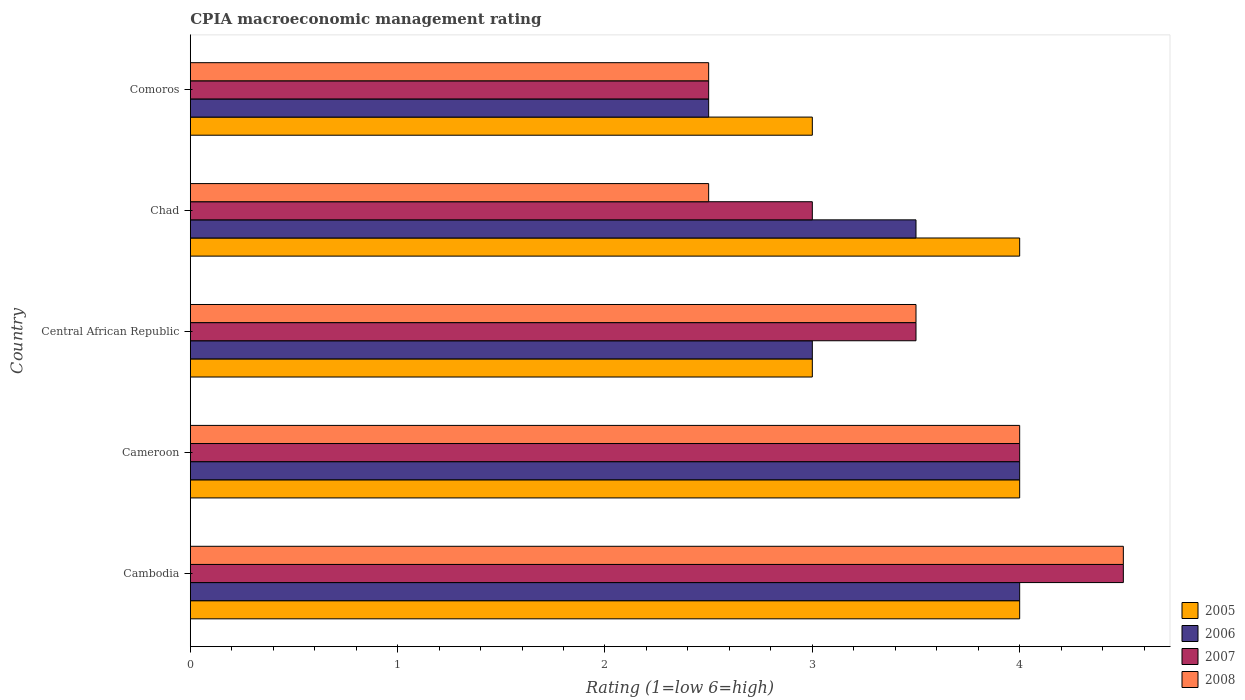Are the number of bars per tick equal to the number of legend labels?
Your answer should be very brief. Yes. Are the number of bars on each tick of the Y-axis equal?
Make the answer very short. Yes. How many bars are there on the 5th tick from the top?
Provide a succinct answer. 4. What is the label of the 1st group of bars from the top?
Your response must be concise. Comoros. What is the CPIA rating in 2007 in Cambodia?
Your answer should be very brief. 4.5. In which country was the CPIA rating in 2006 maximum?
Make the answer very short. Cambodia. In which country was the CPIA rating in 2006 minimum?
Provide a short and direct response. Comoros. What is the total CPIA rating in 2007 in the graph?
Your response must be concise. 17.5. What is the difference between the CPIA rating in 2006 in Cameroon and that in Central African Republic?
Your response must be concise. 1. What is the difference between the CPIA rating in 2005 in Comoros and the CPIA rating in 2007 in Cambodia?
Your answer should be compact. -1.5. What is the average CPIA rating in 2005 per country?
Keep it short and to the point. 3.6. What is the difference between the CPIA rating in 2005 and CPIA rating in 2007 in Comoros?
Keep it short and to the point. 0.5. What is the ratio of the CPIA rating in 2005 in Cambodia to that in Central African Republic?
Offer a very short reply. 1.33. Is the CPIA rating in 2008 in Cambodia less than that in Comoros?
Your answer should be very brief. No. What is the difference between the highest and the second highest CPIA rating in 2008?
Ensure brevity in your answer.  0.5. What is the difference between the highest and the lowest CPIA rating in 2005?
Your answer should be compact. 1. In how many countries, is the CPIA rating in 2006 greater than the average CPIA rating in 2006 taken over all countries?
Give a very brief answer. 3. Is it the case that in every country, the sum of the CPIA rating in 2007 and CPIA rating in 2008 is greater than the sum of CPIA rating in 2005 and CPIA rating in 2006?
Provide a short and direct response. No. What does the 1st bar from the top in Chad represents?
Your answer should be very brief. 2008. How many countries are there in the graph?
Make the answer very short. 5. Does the graph contain any zero values?
Offer a very short reply. No. How are the legend labels stacked?
Give a very brief answer. Vertical. What is the title of the graph?
Give a very brief answer. CPIA macroeconomic management rating. What is the label or title of the X-axis?
Make the answer very short. Rating (1=low 6=high). What is the label or title of the Y-axis?
Provide a succinct answer. Country. What is the Rating (1=low 6=high) of 2005 in Cambodia?
Make the answer very short. 4. What is the Rating (1=low 6=high) in 2008 in Cambodia?
Your answer should be very brief. 4.5. What is the Rating (1=low 6=high) of 2005 in Cameroon?
Provide a succinct answer. 4. What is the Rating (1=low 6=high) in 2005 in Central African Republic?
Make the answer very short. 3. What is the Rating (1=low 6=high) in 2007 in Chad?
Give a very brief answer. 3. What is the Rating (1=low 6=high) in 2008 in Chad?
Offer a terse response. 2.5. What is the Rating (1=low 6=high) of 2005 in Comoros?
Offer a terse response. 3. What is the Rating (1=low 6=high) of 2006 in Comoros?
Provide a succinct answer. 2.5. What is the Rating (1=low 6=high) of 2008 in Comoros?
Ensure brevity in your answer.  2.5. Across all countries, what is the maximum Rating (1=low 6=high) of 2008?
Your answer should be compact. 4.5. Across all countries, what is the minimum Rating (1=low 6=high) of 2007?
Your answer should be very brief. 2.5. Across all countries, what is the minimum Rating (1=low 6=high) of 2008?
Provide a succinct answer. 2.5. What is the total Rating (1=low 6=high) of 2006 in the graph?
Provide a succinct answer. 17. What is the total Rating (1=low 6=high) of 2007 in the graph?
Provide a succinct answer. 17.5. What is the total Rating (1=low 6=high) in 2008 in the graph?
Ensure brevity in your answer.  17. What is the difference between the Rating (1=low 6=high) in 2006 in Cambodia and that in Cameroon?
Make the answer very short. 0. What is the difference between the Rating (1=low 6=high) in 2007 in Cambodia and that in Cameroon?
Give a very brief answer. 0.5. What is the difference between the Rating (1=low 6=high) in 2008 in Cambodia and that in Cameroon?
Offer a very short reply. 0.5. What is the difference between the Rating (1=low 6=high) of 2005 in Cambodia and that in Central African Republic?
Your answer should be very brief. 1. What is the difference between the Rating (1=low 6=high) of 2006 in Cambodia and that in Central African Republic?
Your answer should be very brief. 1. What is the difference between the Rating (1=low 6=high) of 2005 in Cambodia and that in Chad?
Offer a terse response. 0. What is the difference between the Rating (1=low 6=high) in 2008 in Cambodia and that in Chad?
Provide a short and direct response. 2. What is the difference between the Rating (1=low 6=high) in 2006 in Cambodia and that in Comoros?
Your answer should be compact. 1.5. What is the difference between the Rating (1=low 6=high) of 2007 in Cambodia and that in Comoros?
Offer a terse response. 2. What is the difference between the Rating (1=low 6=high) of 2006 in Cameroon and that in Central African Republic?
Your answer should be compact. 1. What is the difference between the Rating (1=low 6=high) in 2005 in Cameroon and that in Chad?
Your response must be concise. 0. What is the difference between the Rating (1=low 6=high) in 2008 in Cameroon and that in Comoros?
Keep it short and to the point. 1.5. What is the difference between the Rating (1=low 6=high) in 2006 in Central African Republic and that in Chad?
Your response must be concise. -0.5. What is the difference between the Rating (1=low 6=high) of 2007 in Central African Republic and that in Chad?
Give a very brief answer. 0.5. What is the difference between the Rating (1=low 6=high) in 2008 in Central African Republic and that in Chad?
Your response must be concise. 1. What is the difference between the Rating (1=low 6=high) in 2005 in Central African Republic and that in Comoros?
Your response must be concise. 0. What is the difference between the Rating (1=low 6=high) in 2008 in Central African Republic and that in Comoros?
Give a very brief answer. 1. What is the difference between the Rating (1=low 6=high) of 2005 in Chad and that in Comoros?
Keep it short and to the point. 1. What is the difference between the Rating (1=low 6=high) in 2006 in Chad and that in Comoros?
Provide a short and direct response. 1. What is the difference between the Rating (1=low 6=high) of 2005 in Cambodia and the Rating (1=low 6=high) of 2007 in Cameroon?
Ensure brevity in your answer.  0. What is the difference between the Rating (1=low 6=high) of 2005 in Cambodia and the Rating (1=low 6=high) of 2008 in Cameroon?
Make the answer very short. 0. What is the difference between the Rating (1=low 6=high) of 2006 in Cambodia and the Rating (1=low 6=high) of 2008 in Cameroon?
Your answer should be compact. 0. What is the difference between the Rating (1=low 6=high) in 2006 in Cambodia and the Rating (1=low 6=high) in 2007 in Central African Republic?
Offer a terse response. 0.5. What is the difference between the Rating (1=low 6=high) of 2007 in Cambodia and the Rating (1=low 6=high) of 2008 in Central African Republic?
Offer a very short reply. 1. What is the difference between the Rating (1=low 6=high) in 2005 in Cambodia and the Rating (1=low 6=high) in 2006 in Chad?
Ensure brevity in your answer.  0.5. What is the difference between the Rating (1=low 6=high) in 2005 in Cambodia and the Rating (1=low 6=high) in 2007 in Chad?
Offer a very short reply. 1. What is the difference between the Rating (1=low 6=high) of 2005 in Cambodia and the Rating (1=low 6=high) of 2008 in Chad?
Ensure brevity in your answer.  1.5. What is the difference between the Rating (1=low 6=high) of 2006 in Cambodia and the Rating (1=low 6=high) of 2008 in Chad?
Provide a succinct answer. 1.5. What is the difference between the Rating (1=low 6=high) in 2007 in Cambodia and the Rating (1=low 6=high) in 2008 in Chad?
Offer a terse response. 2. What is the difference between the Rating (1=low 6=high) in 2005 in Cambodia and the Rating (1=low 6=high) in 2007 in Comoros?
Provide a short and direct response. 1.5. What is the difference between the Rating (1=low 6=high) of 2006 in Cambodia and the Rating (1=low 6=high) of 2008 in Comoros?
Keep it short and to the point. 1.5. What is the difference between the Rating (1=low 6=high) in 2005 in Cameroon and the Rating (1=low 6=high) in 2006 in Central African Republic?
Your response must be concise. 1. What is the difference between the Rating (1=low 6=high) in 2005 in Cameroon and the Rating (1=low 6=high) in 2007 in Central African Republic?
Provide a short and direct response. 0.5. What is the difference between the Rating (1=low 6=high) in 2005 in Cameroon and the Rating (1=low 6=high) in 2008 in Central African Republic?
Offer a terse response. 0.5. What is the difference between the Rating (1=low 6=high) in 2006 in Cameroon and the Rating (1=low 6=high) in 2007 in Central African Republic?
Keep it short and to the point. 0.5. What is the difference between the Rating (1=low 6=high) of 2005 in Cameroon and the Rating (1=low 6=high) of 2006 in Chad?
Provide a succinct answer. 0.5. What is the difference between the Rating (1=low 6=high) in 2006 in Cameroon and the Rating (1=low 6=high) in 2007 in Chad?
Give a very brief answer. 1. What is the difference between the Rating (1=low 6=high) in 2005 in Cameroon and the Rating (1=low 6=high) in 2006 in Comoros?
Provide a short and direct response. 1.5. What is the difference between the Rating (1=low 6=high) of 2005 in Cameroon and the Rating (1=low 6=high) of 2008 in Comoros?
Your answer should be compact. 1.5. What is the difference between the Rating (1=low 6=high) of 2006 in Cameroon and the Rating (1=low 6=high) of 2007 in Comoros?
Your answer should be compact. 1.5. What is the difference between the Rating (1=low 6=high) of 2007 in Cameroon and the Rating (1=low 6=high) of 2008 in Comoros?
Your answer should be very brief. 1.5. What is the difference between the Rating (1=low 6=high) in 2005 in Central African Republic and the Rating (1=low 6=high) in 2006 in Chad?
Your answer should be very brief. -0.5. What is the difference between the Rating (1=low 6=high) of 2006 in Central African Republic and the Rating (1=low 6=high) of 2007 in Chad?
Provide a succinct answer. 0. What is the difference between the Rating (1=low 6=high) of 2005 in Central African Republic and the Rating (1=low 6=high) of 2006 in Comoros?
Provide a short and direct response. 0.5. What is the difference between the Rating (1=low 6=high) in 2005 in Central African Republic and the Rating (1=low 6=high) in 2008 in Comoros?
Make the answer very short. 0.5. What is the difference between the Rating (1=low 6=high) of 2006 in Central African Republic and the Rating (1=low 6=high) of 2008 in Comoros?
Your answer should be compact. 0.5. What is the difference between the Rating (1=low 6=high) in 2005 in Chad and the Rating (1=low 6=high) in 2006 in Comoros?
Offer a terse response. 1.5. What is the difference between the Rating (1=low 6=high) of 2006 in Chad and the Rating (1=low 6=high) of 2007 in Comoros?
Your answer should be very brief. 1. What is the difference between the Rating (1=low 6=high) of 2007 in Chad and the Rating (1=low 6=high) of 2008 in Comoros?
Keep it short and to the point. 0.5. What is the difference between the Rating (1=low 6=high) of 2006 and Rating (1=low 6=high) of 2008 in Cambodia?
Offer a terse response. -0.5. What is the difference between the Rating (1=low 6=high) in 2005 and Rating (1=low 6=high) in 2006 in Cameroon?
Your response must be concise. 0. What is the difference between the Rating (1=low 6=high) of 2005 and Rating (1=low 6=high) of 2008 in Cameroon?
Your answer should be compact. 0. What is the difference between the Rating (1=low 6=high) in 2005 and Rating (1=low 6=high) in 2007 in Central African Republic?
Provide a succinct answer. -0.5. What is the difference between the Rating (1=low 6=high) in 2007 and Rating (1=low 6=high) in 2008 in Central African Republic?
Give a very brief answer. 0. What is the difference between the Rating (1=low 6=high) of 2005 and Rating (1=low 6=high) of 2006 in Comoros?
Your answer should be very brief. 0.5. What is the difference between the Rating (1=low 6=high) in 2005 and Rating (1=low 6=high) in 2008 in Comoros?
Offer a very short reply. 0.5. What is the ratio of the Rating (1=low 6=high) of 2005 in Cambodia to that in Cameroon?
Give a very brief answer. 1. What is the ratio of the Rating (1=low 6=high) of 2008 in Cambodia to that in Cameroon?
Provide a short and direct response. 1.12. What is the ratio of the Rating (1=low 6=high) in 2005 in Cambodia to that in Central African Republic?
Provide a short and direct response. 1.33. What is the ratio of the Rating (1=low 6=high) of 2006 in Cambodia to that in Central African Republic?
Keep it short and to the point. 1.33. What is the ratio of the Rating (1=low 6=high) of 2007 in Cambodia to that in Central African Republic?
Offer a very short reply. 1.29. What is the ratio of the Rating (1=low 6=high) in 2008 in Cambodia to that in Central African Republic?
Provide a succinct answer. 1.29. What is the ratio of the Rating (1=low 6=high) in 2007 in Cambodia to that in Chad?
Your answer should be compact. 1.5. What is the ratio of the Rating (1=low 6=high) of 2008 in Cambodia to that in Chad?
Your response must be concise. 1.8. What is the ratio of the Rating (1=low 6=high) in 2006 in Cambodia to that in Comoros?
Offer a terse response. 1.6. What is the ratio of the Rating (1=low 6=high) in 2007 in Cambodia to that in Comoros?
Your answer should be very brief. 1.8. What is the ratio of the Rating (1=low 6=high) of 2005 in Cameroon to that in Central African Republic?
Make the answer very short. 1.33. What is the ratio of the Rating (1=low 6=high) in 2006 in Cameroon to that in Chad?
Offer a very short reply. 1.14. What is the ratio of the Rating (1=low 6=high) of 2008 in Cameroon to that in Chad?
Ensure brevity in your answer.  1.6. What is the ratio of the Rating (1=low 6=high) of 2005 in Cameroon to that in Comoros?
Your answer should be compact. 1.33. What is the ratio of the Rating (1=low 6=high) in 2006 in Cameroon to that in Comoros?
Your answer should be compact. 1.6. What is the ratio of the Rating (1=low 6=high) of 2008 in Cameroon to that in Comoros?
Offer a terse response. 1.6. What is the ratio of the Rating (1=low 6=high) in 2005 in Central African Republic to that in Chad?
Make the answer very short. 0.75. What is the ratio of the Rating (1=low 6=high) of 2006 in Central African Republic to that in Chad?
Ensure brevity in your answer.  0.86. What is the ratio of the Rating (1=low 6=high) in 2007 in Central African Republic to that in Chad?
Offer a terse response. 1.17. What is the ratio of the Rating (1=low 6=high) of 2008 in Central African Republic to that in Chad?
Provide a succinct answer. 1.4. What is the ratio of the Rating (1=low 6=high) in 2006 in Central African Republic to that in Comoros?
Your response must be concise. 1.2. What is the ratio of the Rating (1=low 6=high) of 2008 in Central African Republic to that in Comoros?
Provide a short and direct response. 1.4. What is the ratio of the Rating (1=low 6=high) in 2006 in Chad to that in Comoros?
Ensure brevity in your answer.  1.4. What is the ratio of the Rating (1=low 6=high) in 2008 in Chad to that in Comoros?
Your answer should be very brief. 1. What is the difference between the highest and the second highest Rating (1=low 6=high) of 2006?
Keep it short and to the point. 0. What is the difference between the highest and the second highest Rating (1=low 6=high) of 2007?
Make the answer very short. 0.5. What is the difference between the highest and the lowest Rating (1=low 6=high) in 2005?
Ensure brevity in your answer.  1. What is the difference between the highest and the lowest Rating (1=low 6=high) in 2007?
Provide a short and direct response. 2. 